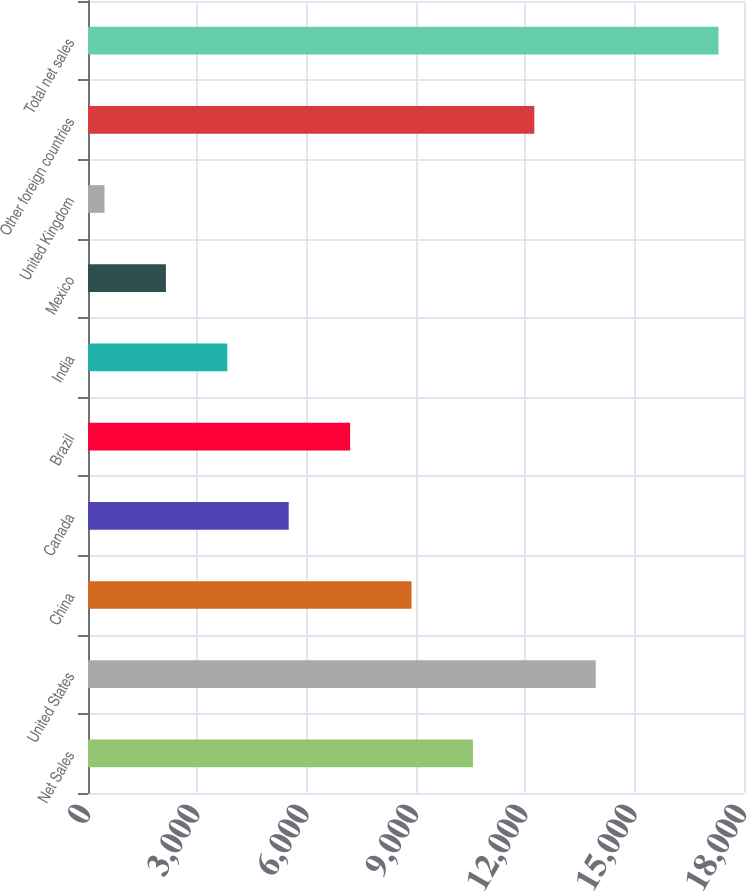Convert chart to OTSL. <chart><loc_0><loc_0><loc_500><loc_500><bar_chart><fcel>Net Sales<fcel>United States<fcel>China<fcel>Canada<fcel>Brazil<fcel>India<fcel>Mexico<fcel>United Kingdom<fcel>Other foreign countries<fcel>Total net sales<nl><fcel>10561.8<fcel>13931.4<fcel>8877<fcel>5507.4<fcel>7192.2<fcel>3822.6<fcel>2137.8<fcel>453<fcel>12246.6<fcel>17301<nl></chart> 